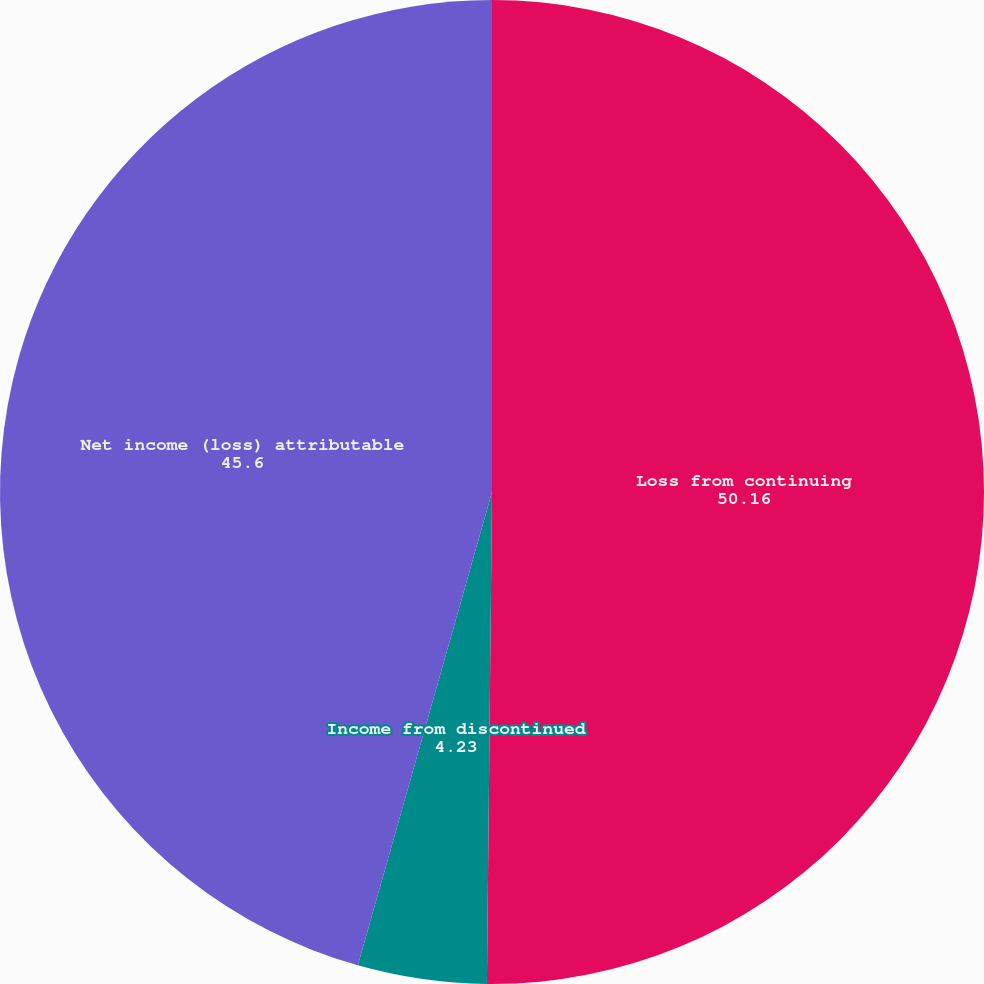<chart> <loc_0><loc_0><loc_500><loc_500><pie_chart><fcel>Loss from continuing<fcel>Income from discontinued<fcel>Net income (loss) attributable<nl><fcel>50.16%<fcel>4.23%<fcel>45.6%<nl></chart> 